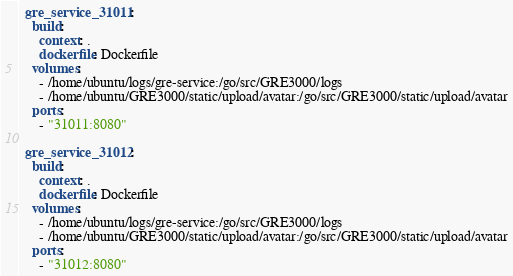<code> <loc_0><loc_0><loc_500><loc_500><_YAML_>  gre_service_31011:
    build:
      context: .
      dockerfile: Dockerfile
    volumes:
      - /home/ubuntu/logs/gre-service:/go/src/GRE3000/logs
      - /home/ubuntu/GRE3000/static/upload/avatar:/go/src/GRE3000/static/upload/avatar
    ports:
      - "31011:8080"

  gre_service_31012:
    build:
      context: .
      dockerfile: Dockerfile
    volumes:
      - /home/ubuntu/logs/gre-service:/go/src/GRE3000/logs
      - /home/ubuntu/GRE3000/static/upload/avatar:/go/src/GRE3000/static/upload/avatar
    ports:
      - "31012:8080"
</code> 